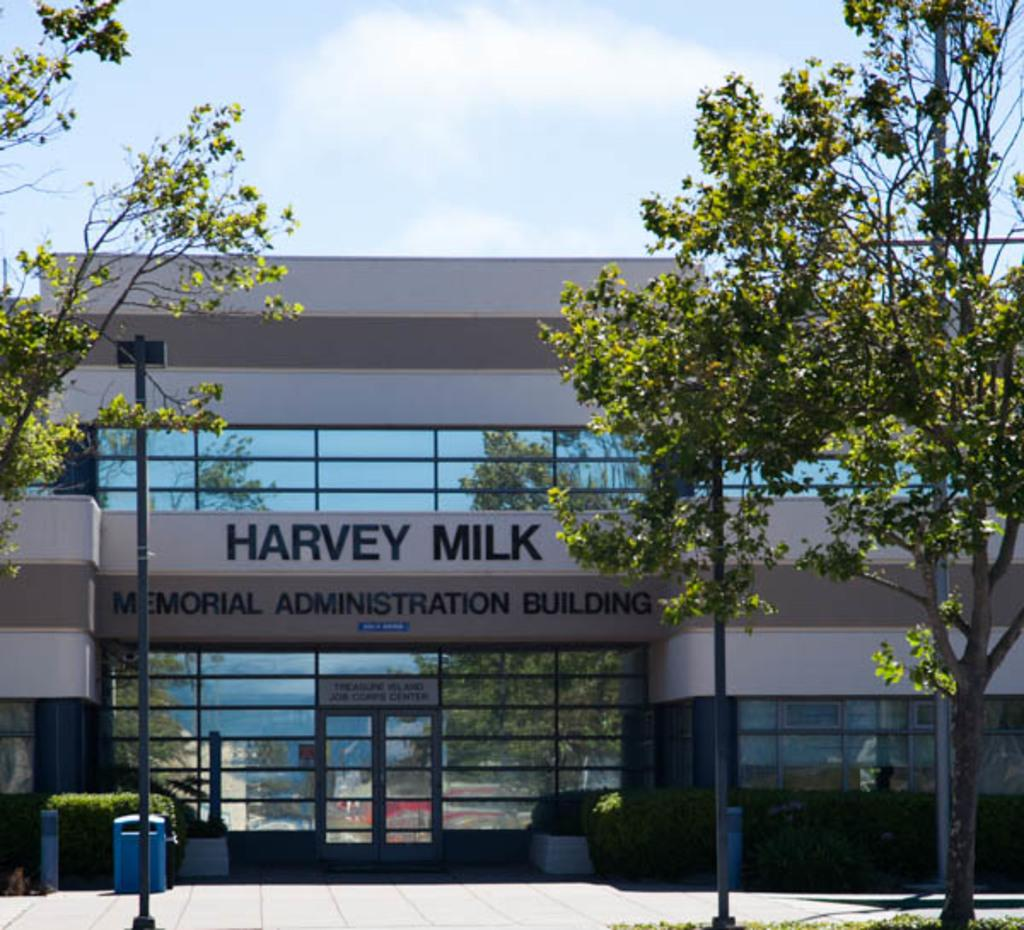What structures can be seen in the image? There are poles, trees, bushes, and a building in the image. What feature does the building have? The building has a door. What is visible behind the building? The sky is visible behind the building. What type of doll is being rewarded with an addition in the image? There is no doll or reward present in the image. 